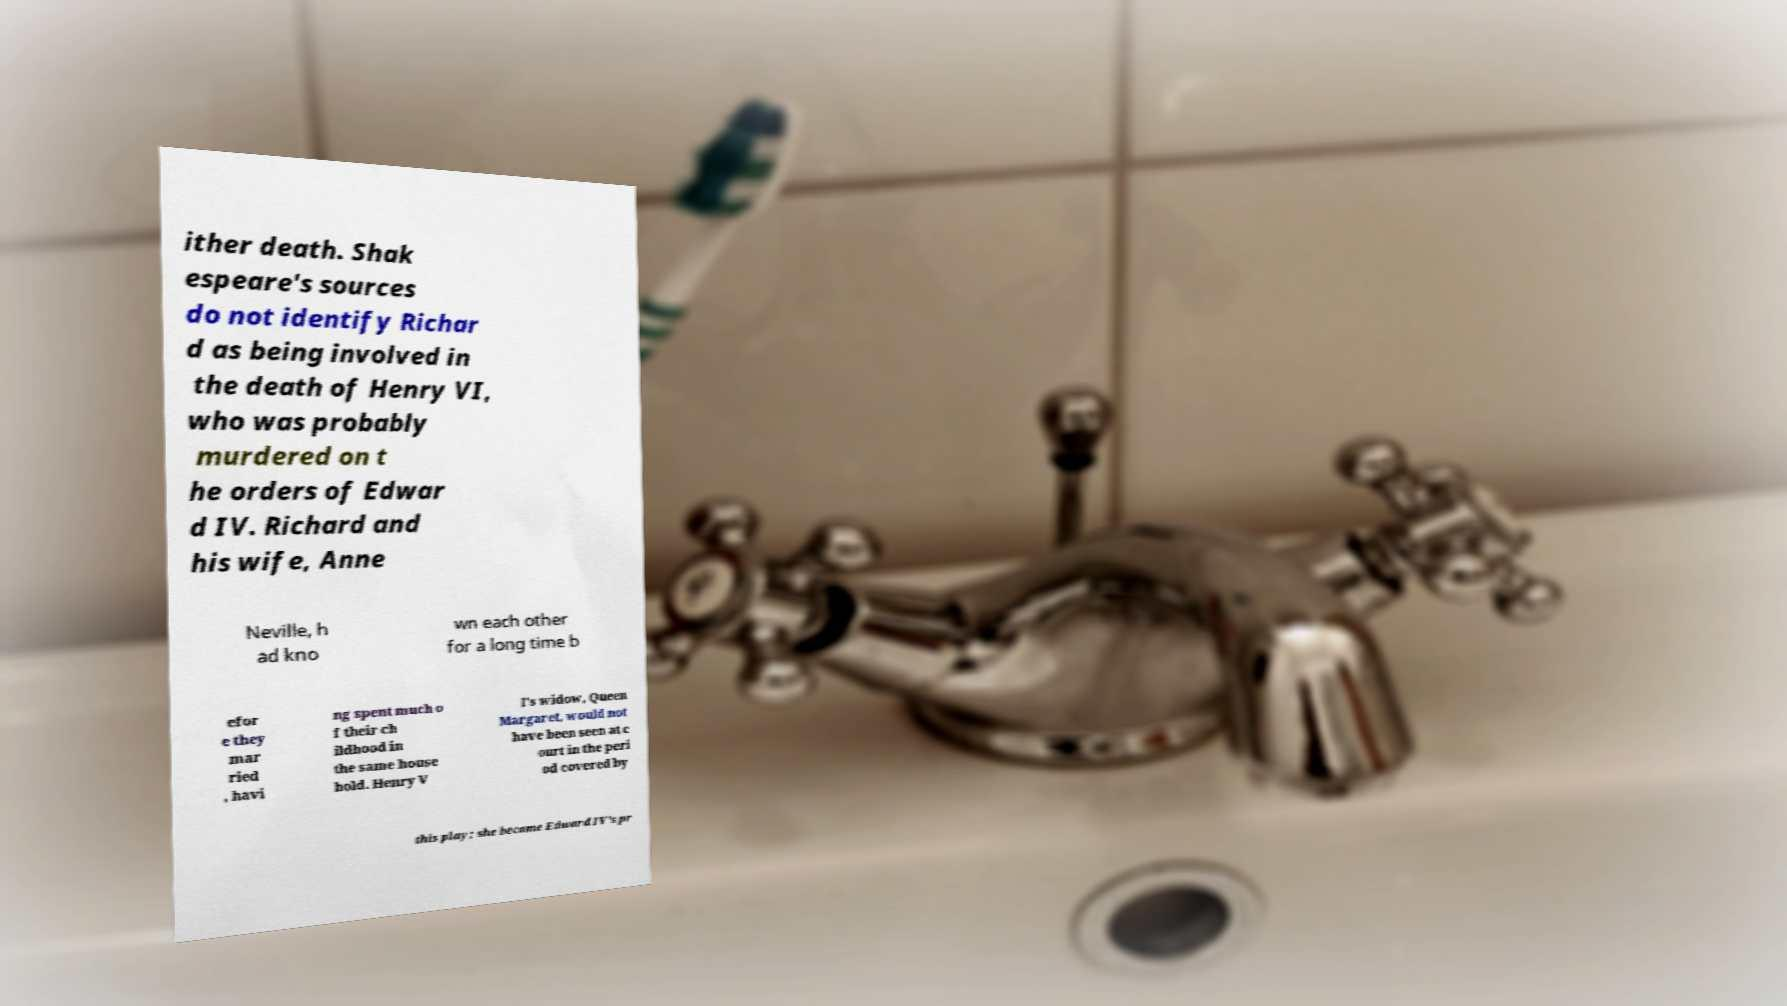I need the written content from this picture converted into text. Can you do that? ither death. Shak espeare's sources do not identify Richar d as being involved in the death of Henry VI, who was probably murdered on t he orders of Edwar d IV. Richard and his wife, Anne Neville, h ad kno wn each other for a long time b efor e they mar ried , havi ng spent much o f their ch ildhood in the same house hold. Henry V I's widow, Queen Margaret, would not have been seen at c ourt in the peri od covered by this play; she became Edward IV's pr 